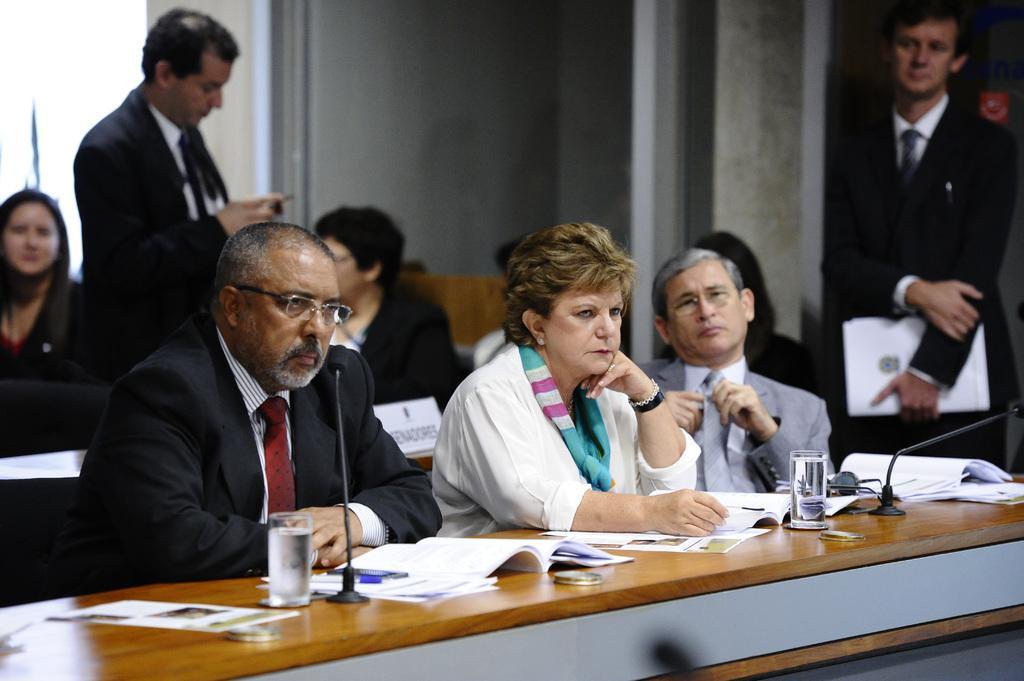In one or two sentences, can you explain what this image depicts? In this image I can see people and two of them are standing and rest all are sitting. I can also see a desk and on this desk I can see mics, few glasses, books and few papers. I can also see most of them are wearing suit and tie. Here I can see two of them are wearing specs. 